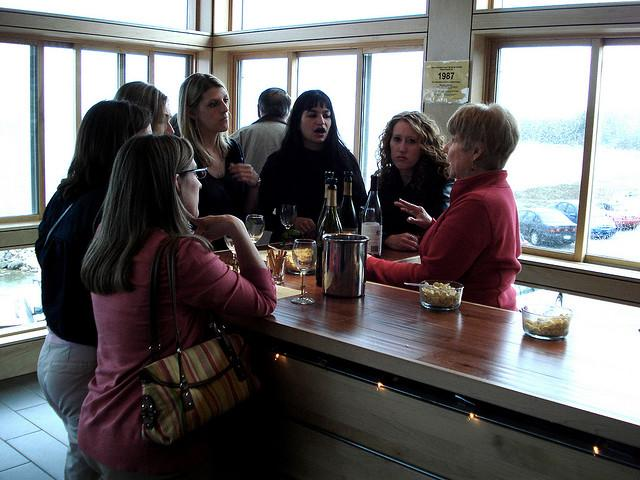What do the ladies here discuss? wine 